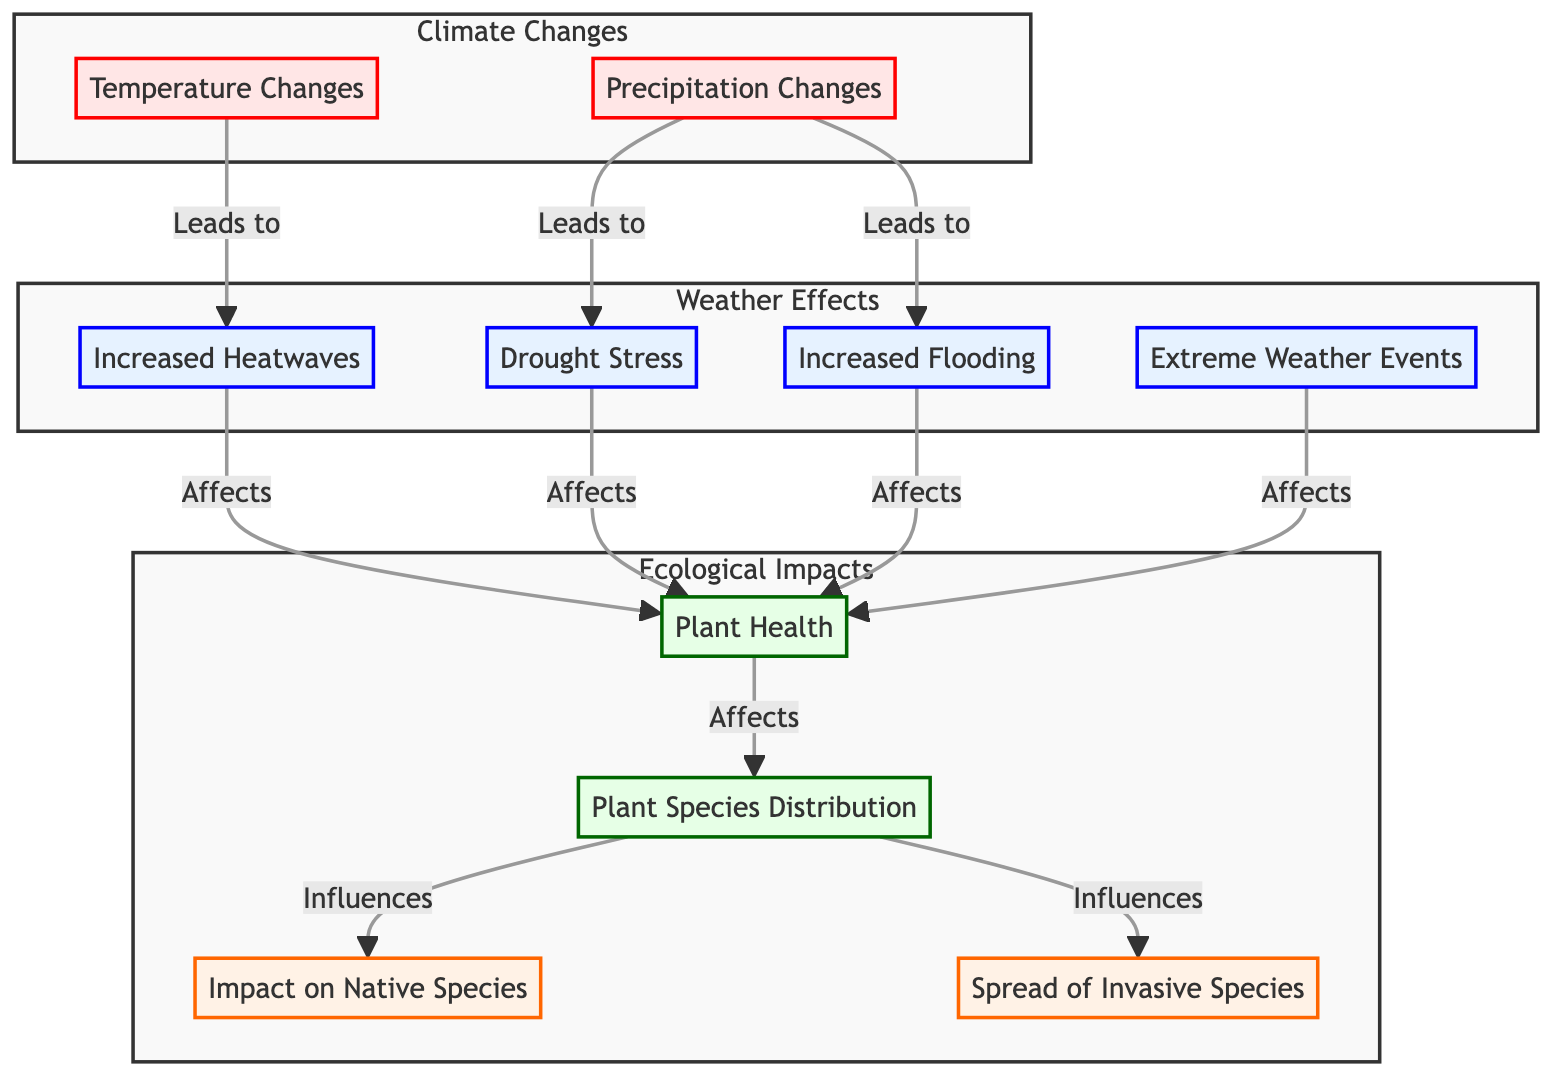What are the two main climate changes depicted in the diagram? The diagram identifies "Temperature Changes" and "Precipitation Changes" as the two primary climate changes, shown as the beginning nodes in the "Climate Changes" subgraph.
Answer: Temperature Changes, Precipitation Changes How many weather effects are represented in the diagram? There are four weather effects shown: "Increased Heatwaves," "Extreme Weather Events," "Drought Stress," and "Increased Flooding." Counting these nodes gives a total of four.
Answer: Four What does increased flooding affect? According to the flowchart, "Increased Flooding" affects "Plant Health," as shown by the direct link from flooding to plant health in the "Weather Effects" subgraph.
Answer: Plant Health Which ecological impact is influenced by plant health? The diagram indicates that "Species Distribution" is influenced by "Plant Health," depicting a directional relationship that highlights the cascading effect of plant health on biodiversity.
Answer: Species Distribution What is the relationship between precipitation change and drought stress? The diagram illustrates a direct relationship, where "Precipitation Changes" lead to "Drought Stress," as indicated by the link showing causation from the change in precipitation to an increase in drought stress.
Answer: Leads to How do heatwaves and flooding both influence plant health? Both "Heatwaves" and "Increased Flooding" are shown as separate pathways that affect "Plant Health." This indicates that both environmental phenomena can deteriorate the health of plants, even though they arise from different causal effects.
Answer: Affect What impact does species distribution have on native species? The flowchart explicitly notes that "Species Distribution" influences "Native Species," which illustrates the importance of plant health and diversity for maintaining the presence of native flora.
Answer: Influences How many components are included in the ecological impacts section? The ecological impacts section comprises four components: "Plant Health," "Species Distribution," "Impact on Native Species," and "Spread of Invasive Species." Counting these reveals a clear total of four distinct components.
Answer: Four What are the effects of extreme weather events depicted? The diagram indicates that "Extreme Weather Events" affect "Plant Health", highlighting a significant environmental concern regarding climate variations impacting urban greenery.
Answer: Plant Health 